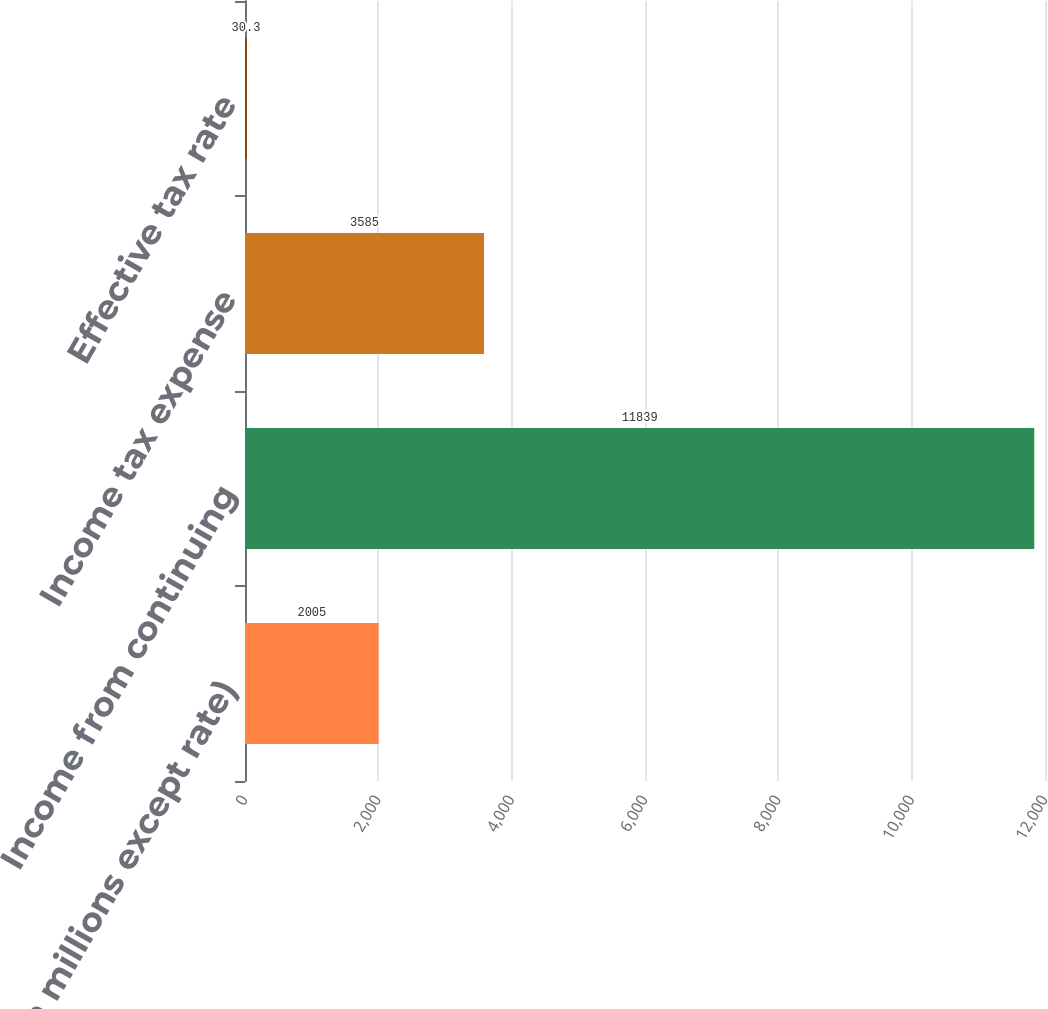Convert chart to OTSL. <chart><loc_0><loc_0><loc_500><loc_500><bar_chart><fcel>(in millions except rate)<fcel>Income from continuing<fcel>Income tax expense<fcel>Effective tax rate<nl><fcel>2005<fcel>11839<fcel>3585<fcel>30.3<nl></chart> 